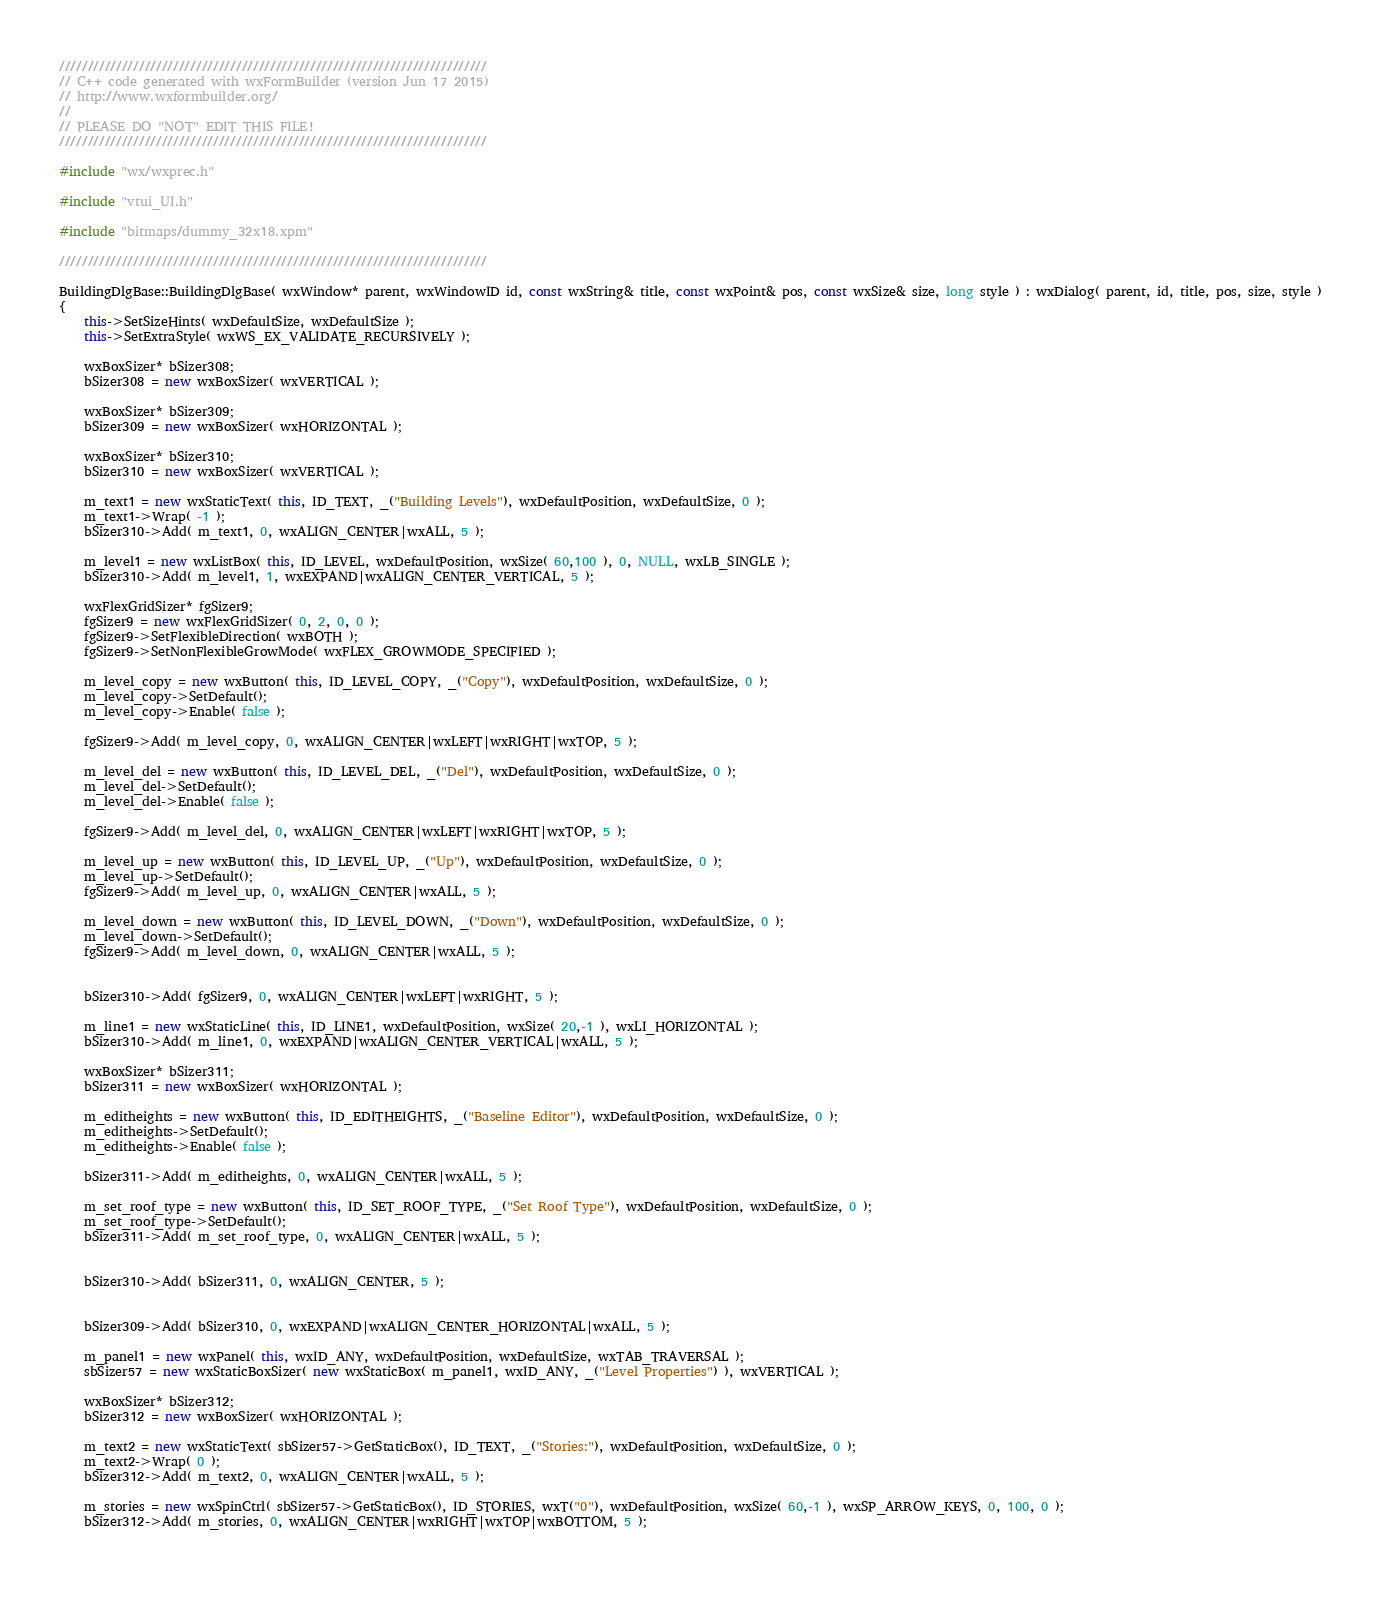<code> <loc_0><loc_0><loc_500><loc_500><_C++_>///////////////////////////////////////////////////////////////////////////
// C++ code generated with wxFormBuilder (version Jun 17 2015)
// http://www.wxformbuilder.org/
//
// PLEASE DO "NOT" EDIT THIS FILE!
///////////////////////////////////////////////////////////////////////////

#include "wx/wxprec.h"

#include "vtui_UI.h"

#include "bitmaps/dummy_32x18.xpm"

///////////////////////////////////////////////////////////////////////////

BuildingDlgBase::BuildingDlgBase( wxWindow* parent, wxWindowID id, const wxString& title, const wxPoint& pos, const wxSize& size, long style ) : wxDialog( parent, id, title, pos, size, style )
{
	this->SetSizeHints( wxDefaultSize, wxDefaultSize );
	this->SetExtraStyle( wxWS_EX_VALIDATE_RECURSIVELY );
	
	wxBoxSizer* bSizer308;
	bSizer308 = new wxBoxSizer( wxVERTICAL );
	
	wxBoxSizer* bSizer309;
	bSizer309 = new wxBoxSizer( wxHORIZONTAL );
	
	wxBoxSizer* bSizer310;
	bSizer310 = new wxBoxSizer( wxVERTICAL );
	
	m_text1 = new wxStaticText( this, ID_TEXT, _("Building Levels"), wxDefaultPosition, wxDefaultSize, 0 );
	m_text1->Wrap( -1 );
	bSizer310->Add( m_text1, 0, wxALIGN_CENTER|wxALL, 5 );
	
	m_level1 = new wxListBox( this, ID_LEVEL, wxDefaultPosition, wxSize( 60,100 ), 0, NULL, wxLB_SINGLE ); 
	bSizer310->Add( m_level1, 1, wxEXPAND|wxALIGN_CENTER_VERTICAL, 5 );
	
	wxFlexGridSizer* fgSizer9;
	fgSizer9 = new wxFlexGridSizer( 0, 2, 0, 0 );
	fgSizer9->SetFlexibleDirection( wxBOTH );
	fgSizer9->SetNonFlexibleGrowMode( wxFLEX_GROWMODE_SPECIFIED );
	
	m_level_copy = new wxButton( this, ID_LEVEL_COPY, _("Copy"), wxDefaultPosition, wxDefaultSize, 0 );
	m_level_copy->SetDefault(); 
	m_level_copy->Enable( false );
	
	fgSizer9->Add( m_level_copy, 0, wxALIGN_CENTER|wxLEFT|wxRIGHT|wxTOP, 5 );
	
	m_level_del = new wxButton( this, ID_LEVEL_DEL, _("Del"), wxDefaultPosition, wxDefaultSize, 0 );
	m_level_del->SetDefault(); 
	m_level_del->Enable( false );
	
	fgSizer9->Add( m_level_del, 0, wxALIGN_CENTER|wxLEFT|wxRIGHT|wxTOP, 5 );
	
	m_level_up = new wxButton( this, ID_LEVEL_UP, _("Up"), wxDefaultPosition, wxDefaultSize, 0 );
	m_level_up->SetDefault(); 
	fgSizer9->Add( m_level_up, 0, wxALIGN_CENTER|wxALL, 5 );
	
	m_level_down = new wxButton( this, ID_LEVEL_DOWN, _("Down"), wxDefaultPosition, wxDefaultSize, 0 );
	m_level_down->SetDefault(); 
	fgSizer9->Add( m_level_down, 0, wxALIGN_CENTER|wxALL, 5 );
	
	
	bSizer310->Add( fgSizer9, 0, wxALIGN_CENTER|wxLEFT|wxRIGHT, 5 );
	
	m_line1 = new wxStaticLine( this, ID_LINE1, wxDefaultPosition, wxSize( 20,-1 ), wxLI_HORIZONTAL );
	bSizer310->Add( m_line1, 0, wxEXPAND|wxALIGN_CENTER_VERTICAL|wxALL, 5 );
	
	wxBoxSizer* bSizer311;
	bSizer311 = new wxBoxSizer( wxHORIZONTAL );
	
	m_editheights = new wxButton( this, ID_EDITHEIGHTS, _("Baseline Editor"), wxDefaultPosition, wxDefaultSize, 0 );
	m_editheights->SetDefault(); 
	m_editheights->Enable( false );
	
	bSizer311->Add( m_editheights, 0, wxALIGN_CENTER|wxALL, 5 );
	
	m_set_roof_type = new wxButton( this, ID_SET_ROOF_TYPE, _("Set Roof Type"), wxDefaultPosition, wxDefaultSize, 0 );
	m_set_roof_type->SetDefault(); 
	bSizer311->Add( m_set_roof_type, 0, wxALIGN_CENTER|wxALL, 5 );
	
	
	bSizer310->Add( bSizer311, 0, wxALIGN_CENTER, 5 );
	
	
	bSizer309->Add( bSizer310, 0, wxEXPAND|wxALIGN_CENTER_HORIZONTAL|wxALL, 5 );
	
	m_panel1 = new wxPanel( this, wxID_ANY, wxDefaultPosition, wxDefaultSize, wxTAB_TRAVERSAL );
	sbSizer57 = new wxStaticBoxSizer( new wxStaticBox( m_panel1, wxID_ANY, _("Level Properties") ), wxVERTICAL );
	
	wxBoxSizer* bSizer312;
	bSizer312 = new wxBoxSizer( wxHORIZONTAL );
	
	m_text2 = new wxStaticText( sbSizer57->GetStaticBox(), ID_TEXT, _("Stories:"), wxDefaultPosition, wxDefaultSize, 0 );
	m_text2->Wrap( 0 );
	bSizer312->Add( m_text2, 0, wxALIGN_CENTER|wxALL, 5 );
	
	m_stories = new wxSpinCtrl( sbSizer57->GetStaticBox(), ID_STORIES, wxT("0"), wxDefaultPosition, wxSize( 60,-1 ), wxSP_ARROW_KEYS, 0, 100, 0 );
	bSizer312->Add( m_stories, 0, wxALIGN_CENTER|wxRIGHT|wxTOP|wxBOTTOM, 5 );
	
	</code> 